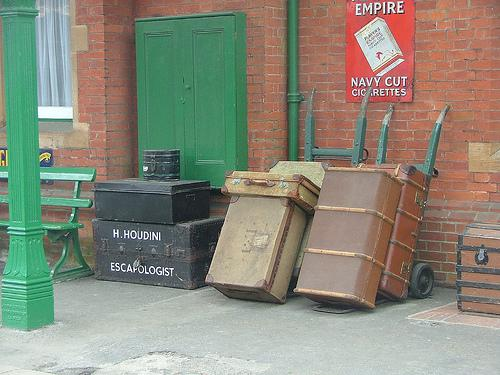Question: why is the street empty?
Choices:
A. It is closed to traffic.
B. The weather is bad.
C. The road is ruined.
D. No people are there.
Answer with the letter. Answer: D Question: where is the green doors?
Choices:
A. In the wall.
B. Around the corner.
C. On the second story.
D. Behind the luggage.
Answer with the letter. Answer: D Question: what is on the sign?
Choices:
A. Apples.
B. Cigarettes.
C. Steaks.
D. Sandwiches.
Answer with the letter. Answer: B Question: when was the photo taken?
Choices:
A. Day time.
B. At night.
C. At sunrise.
D. At evening.
Answer with the letter. Answer: A Question: what color is the pole?
Choices:
A. Green.
B. Blue.
C. Red.
D. Silver.
Answer with the letter. Answer: A 